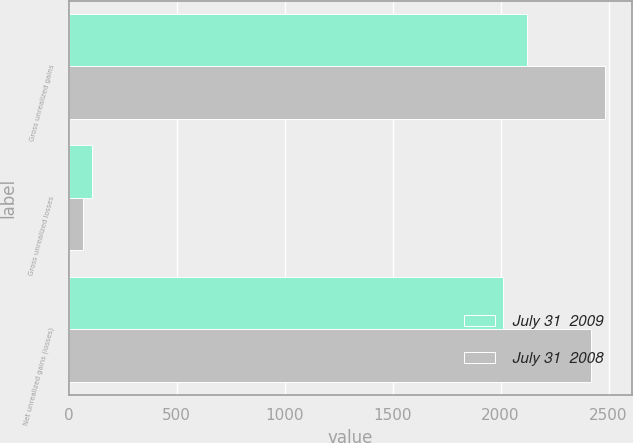<chart> <loc_0><loc_0><loc_500><loc_500><stacked_bar_chart><ecel><fcel>Gross unrealized gains<fcel>Gross unrealized losses<fcel>Net unrealized gains (losses)<nl><fcel>July 31  2009<fcel>2120<fcel>107<fcel>2013<nl><fcel>July 31  2008<fcel>2482<fcel>64<fcel>2418<nl></chart> 